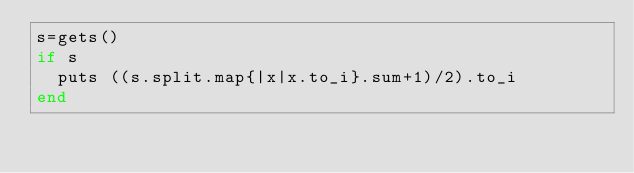Convert code to text. <code><loc_0><loc_0><loc_500><loc_500><_Crystal_>s=gets()
if s
	puts ((s.split.map{|x|x.to_i}.sum+1)/2).to_i
end</code> 